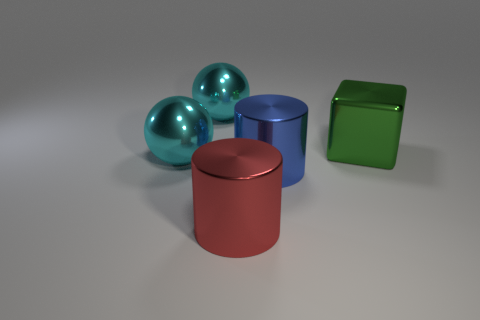What number of red things are made of the same material as the green cube?
Ensure brevity in your answer.  1. Is the shape of the thing that is right of the large blue object the same as  the red metal thing?
Your response must be concise. No. There is a large shiny thing to the right of the blue metallic cylinder; what is its shape?
Provide a short and direct response. Cube. What material is the blue cylinder?
Your answer should be compact. Metal. What is the color of the metal cube that is the same size as the blue shiny cylinder?
Your response must be concise. Green. Is the large red metal object the same shape as the big green metallic object?
Your answer should be compact. No. What material is the thing that is to the right of the big red cylinder and left of the cube?
Your answer should be compact. Metal. The shiny block is what size?
Offer a terse response. Large. What is the color of the other object that is the same shape as the large red thing?
Keep it short and to the point. Blue. Is there any other thing that has the same color as the metallic cube?
Keep it short and to the point. No. 